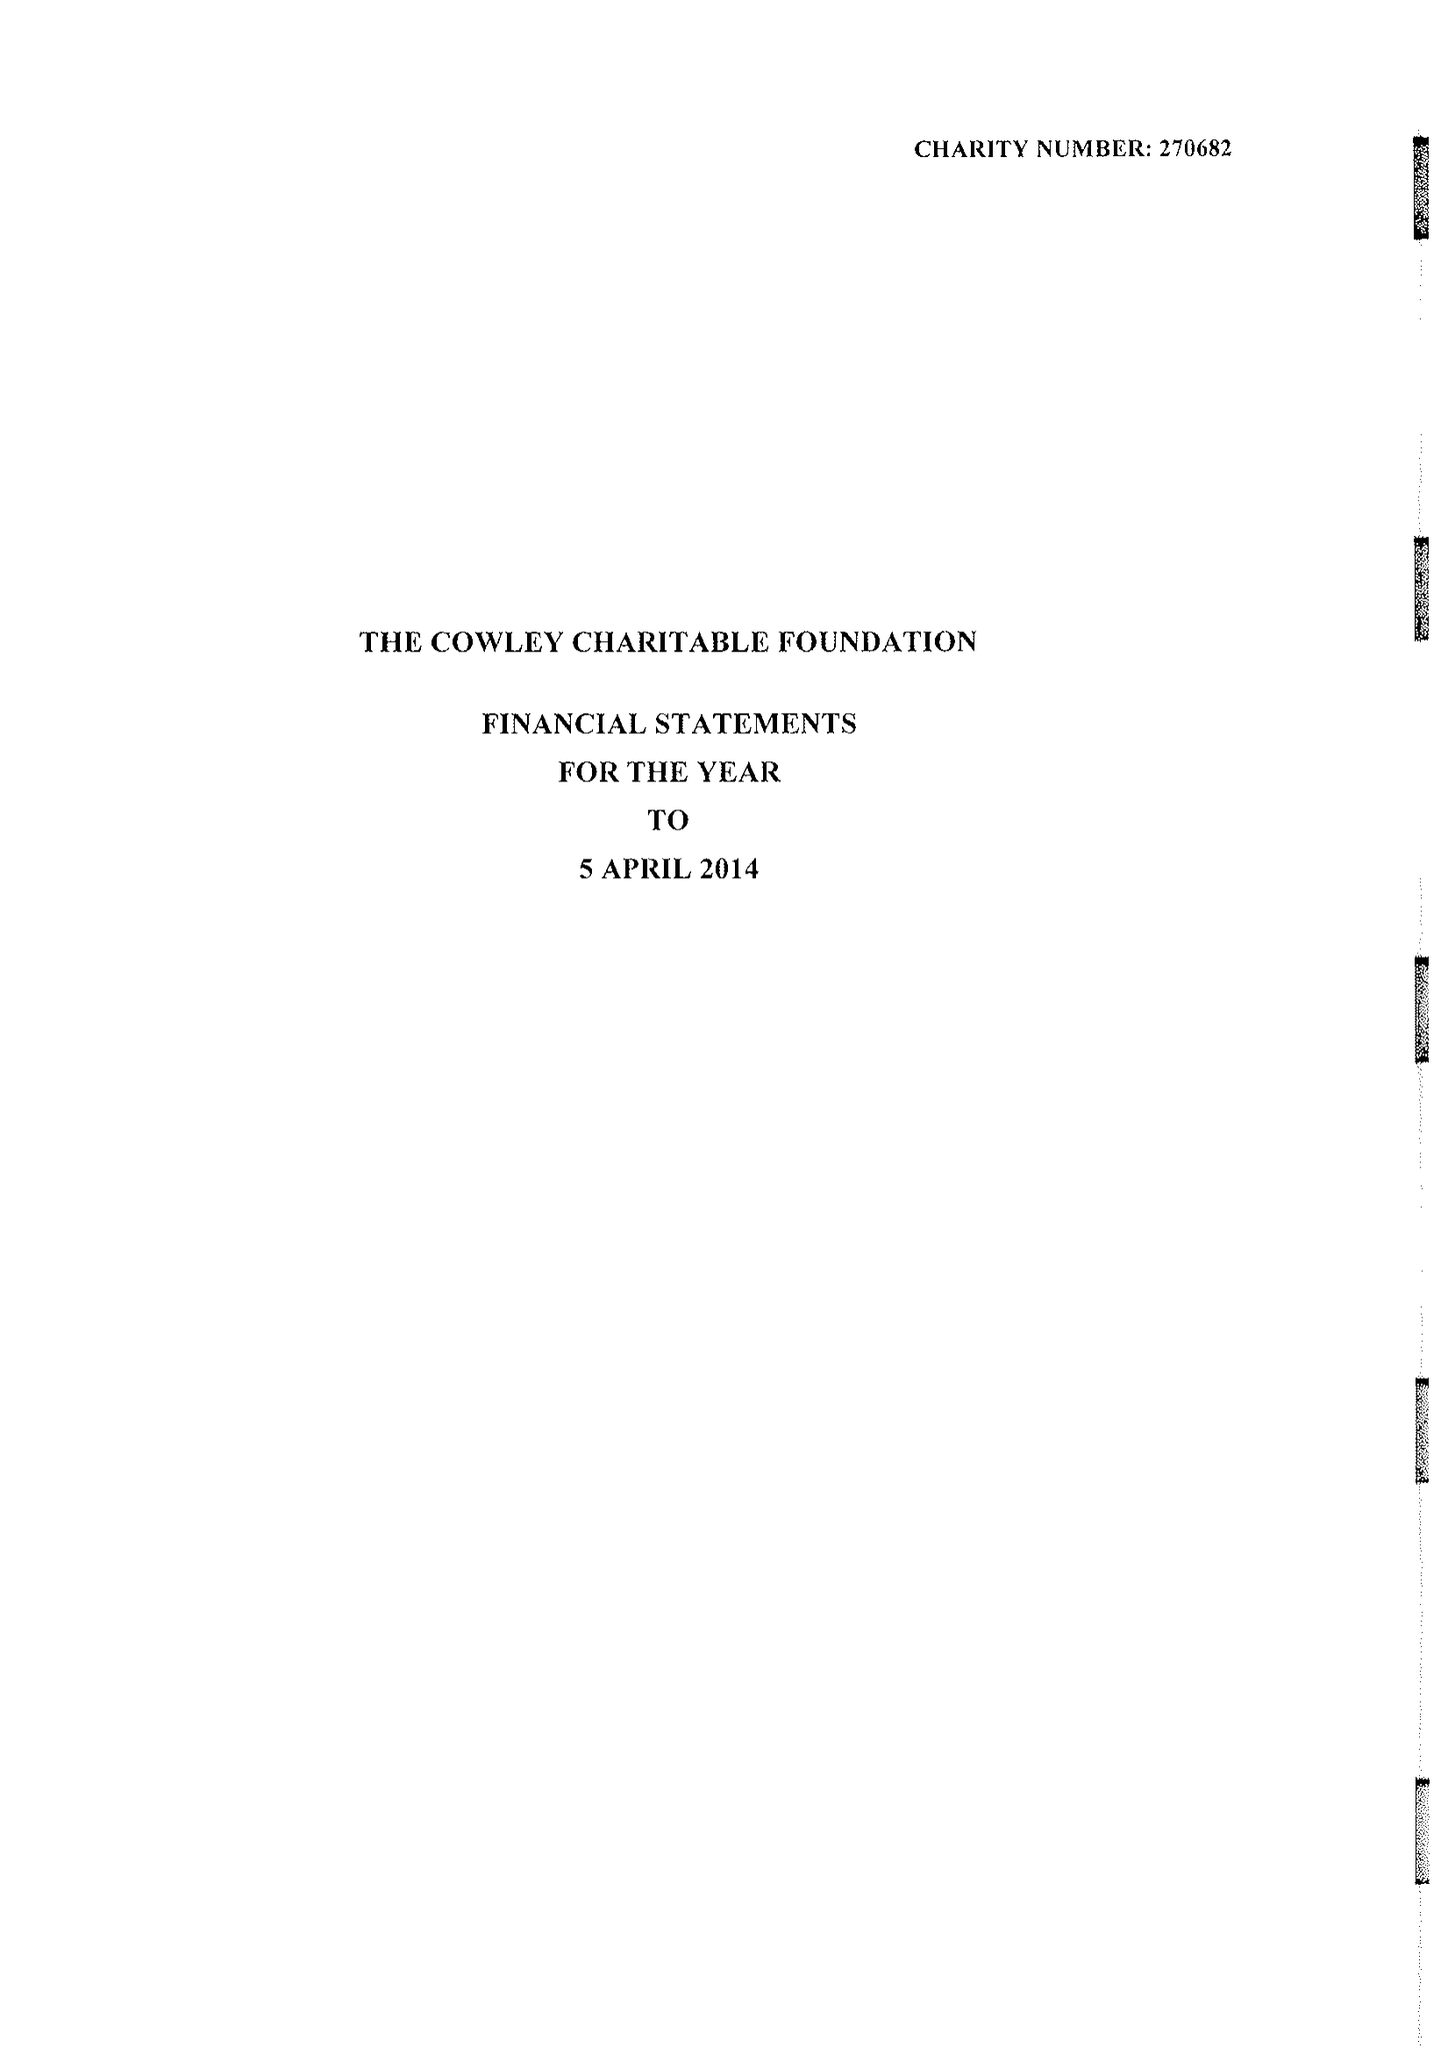What is the value for the address__postcode?
Answer the question using a single word or phrase. SW1W 0BD 